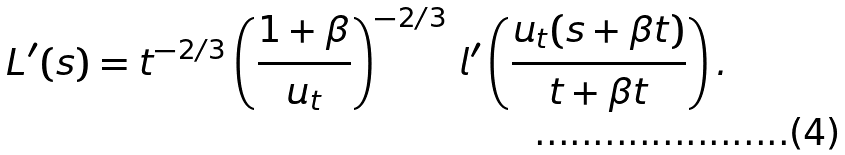Convert formula to latex. <formula><loc_0><loc_0><loc_500><loc_500>L ^ { \prime } ( s ) = t ^ { - 2 / 3 } \left ( \frac { 1 + \beta } { u _ { t } } \right ) ^ { - 2 / 3 } \, l ^ { \prime } \left ( \frac { u _ { t } ( s + \beta t ) } { t + \beta t } \right ) .</formula> 